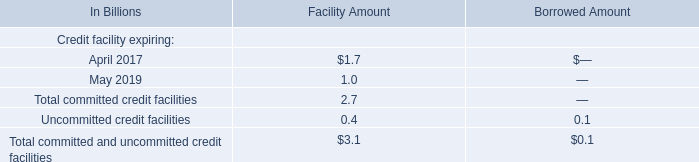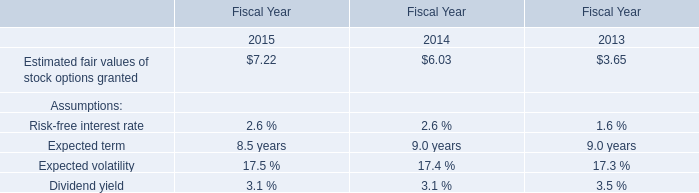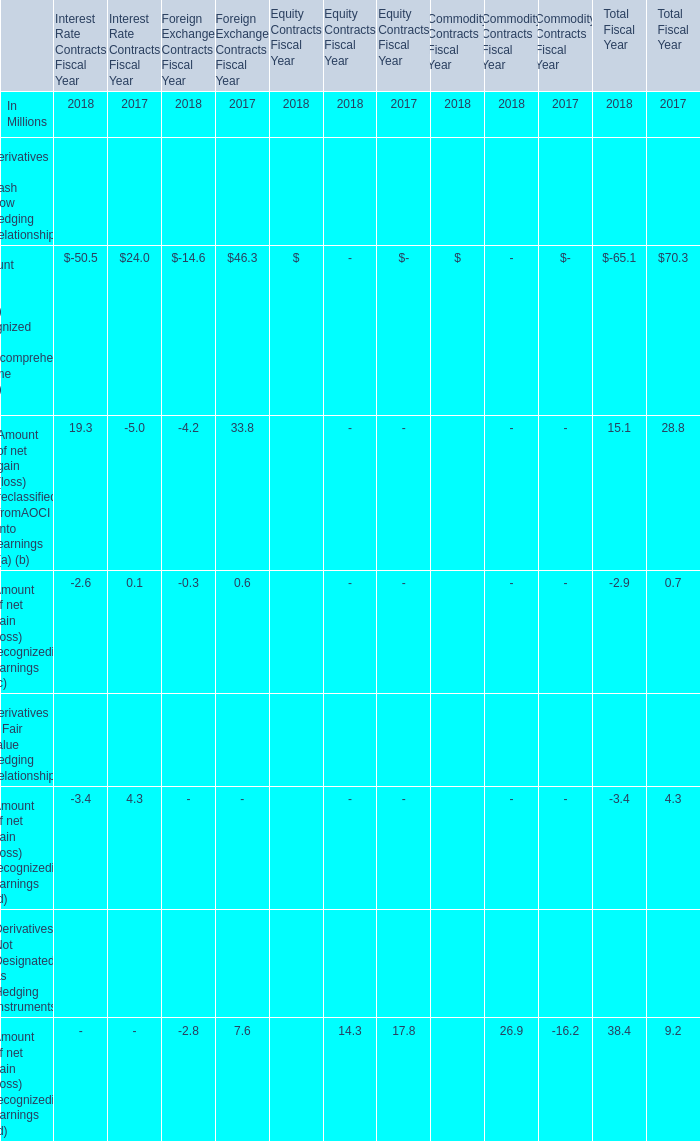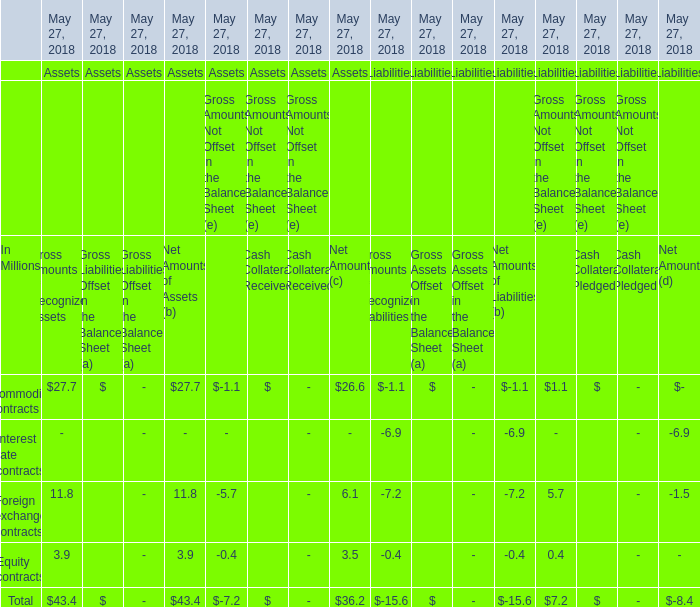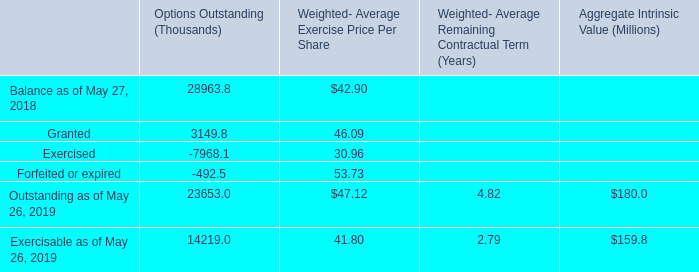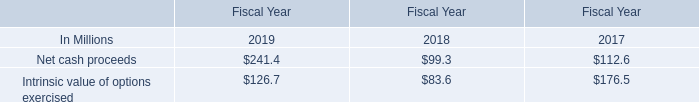In which year is Amount of gain (loss) recognized in othercomprehensive income (OCI) (a) greater than 0? 
Answer: 2017. 